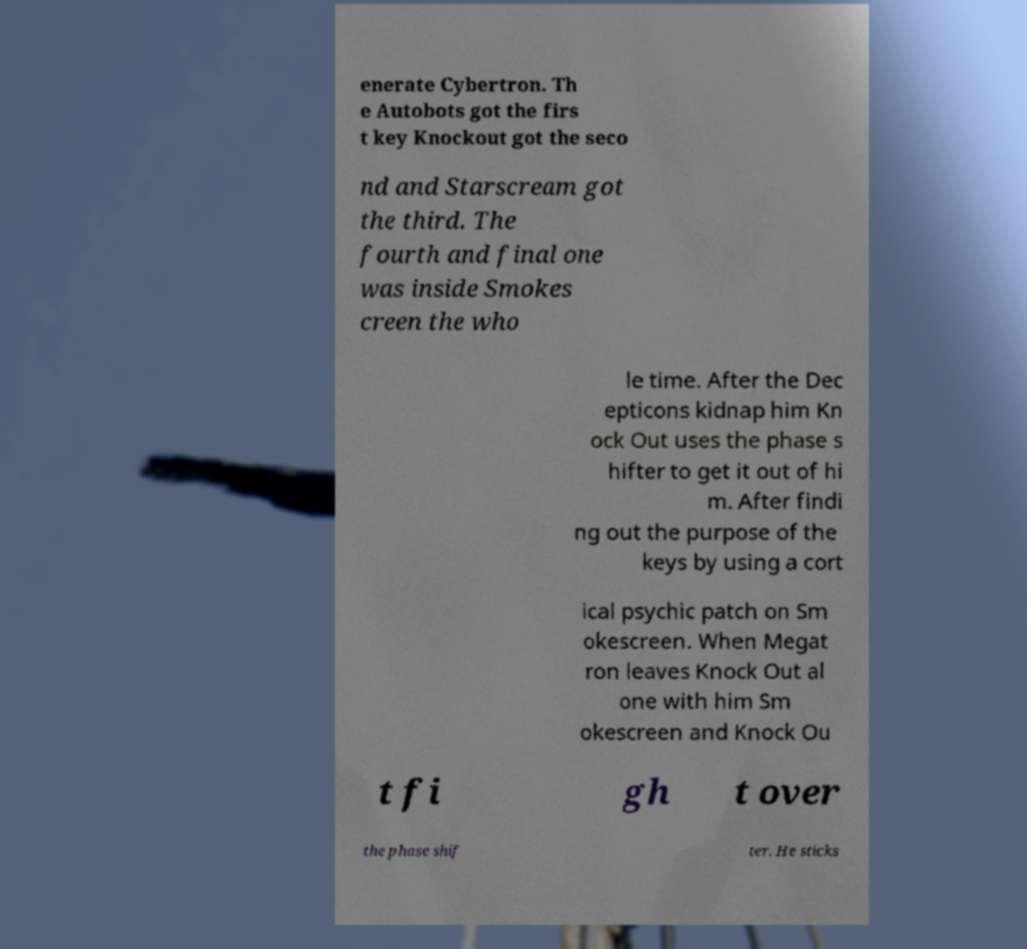Could you assist in decoding the text presented in this image and type it out clearly? enerate Cybertron. Th e Autobots got the firs t key Knockout got the seco nd and Starscream got the third. The fourth and final one was inside Smokes creen the who le time. After the Dec epticons kidnap him Kn ock Out uses the phase s hifter to get it out of hi m. After findi ng out the purpose of the keys by using a cort ical psychic patch on Sm okescreen. When Megat ron leaves Knock Out al one with him Sm okescreen and Knock Ou t fi gh t over the phase shif ter. He sticks 